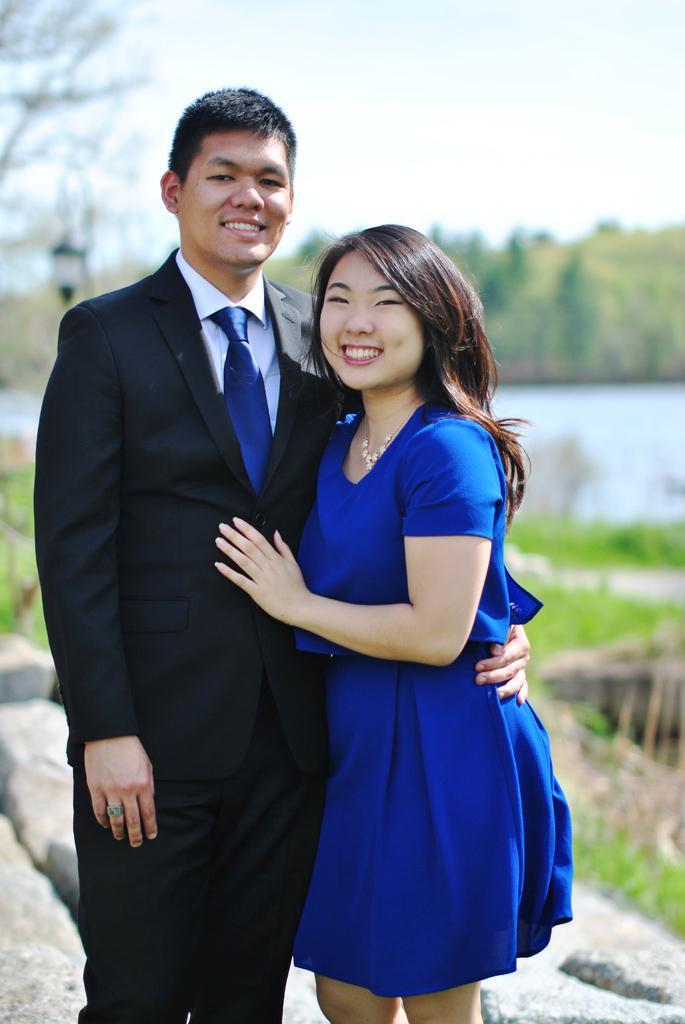Can you describe this image briefly? In this picture I can see a man and a woman standing and smiling, there are rocks, there is water, there are trees, and in the background there is the sky. 